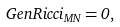<formula> <loc_0><loc_0><loc_500><loc_500>\ G e n R i c c i _ { M N } = 0 ,</formula> 